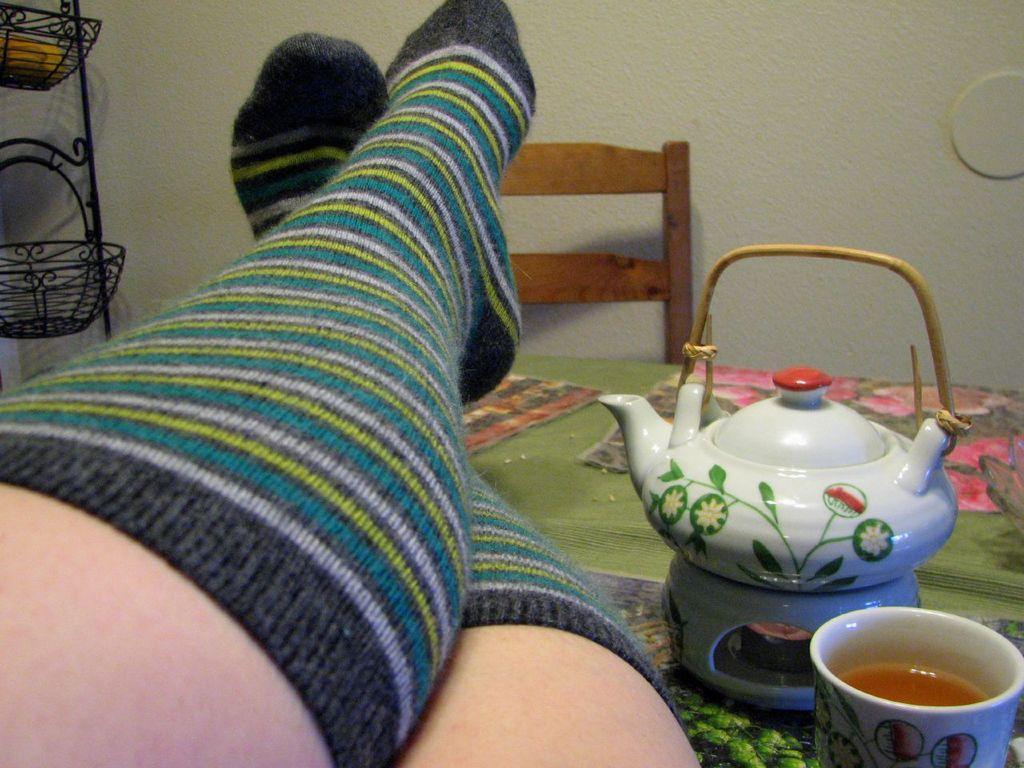How would you summarize this image in a sentence or two? There is a surface. On that there is a kettle, glass with drink and we can see legs of a person with socks. In the back there is a wall and a chair. On the left side there are baskets with stand. 